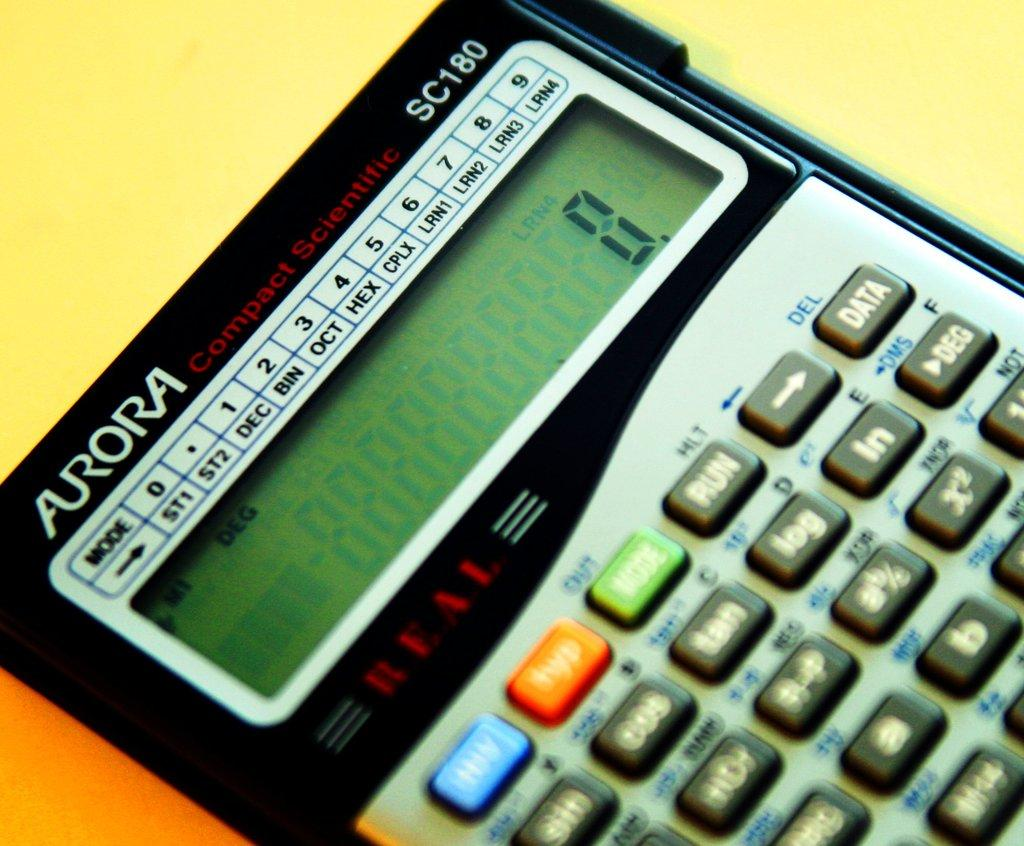<image>
Present a compact description of the photo's key features. Aurora calculator that has blue, orange, and green button. 